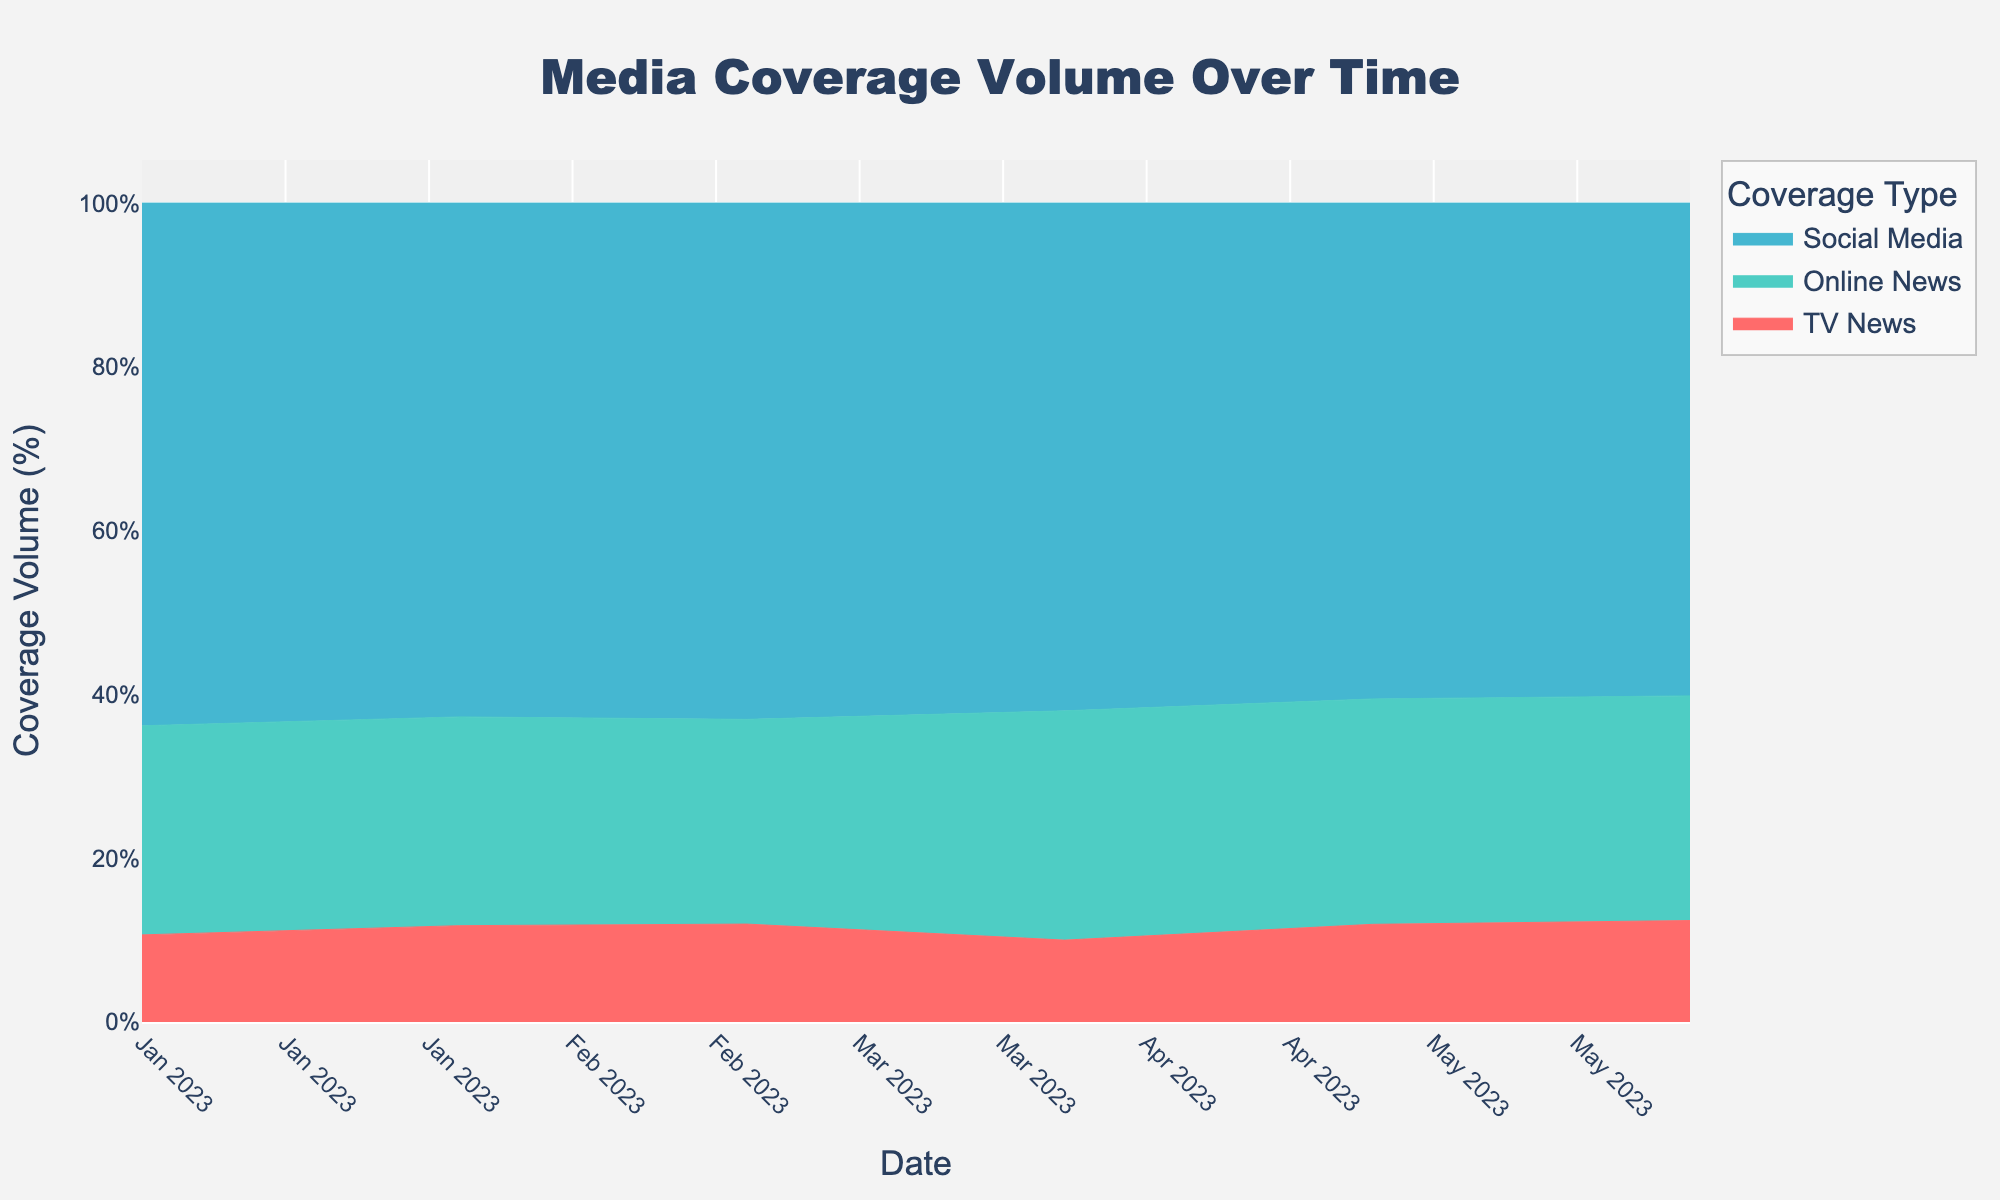When is the peak coverage volume for TV News? Looking at the plot, identify the timeframe where TV News (represented by one of the colors) reaches its highest volume. The peak for TV News is in June 2023.
Answer: June 2023 Which month had the highest overall media coverage? To determine this, sum up the coverage volumes of TV News, Online News, and Social Media for each month and compare them. June 2023 has the highest aggregated media coverage when all three types are combined.
Answer: June 2023 What is the trend of sentiment scores for TV News from January to June 2023? Analyze the pattern of sentiment scores for TV News over time by looking at the y-axis values. The sentiment score for TV News shows an increasing trend from January to June 2023.
Answer: Increasing How does the sentiment score of social media coverage compare to TV News in March 2023? Look at the sentiment scores for both social media and TV News in March. The sentiment score for Social Media (0.45) is lower than that for TV News (0.65) in March 2023.
Answer: Lower Which media coverage type showed the most significant increase in volume from January to June 2023? Compare the coverage volumes of TV News, Online News, and Social Media in January and then in June, and determine which has the largest increase. Social Media showed the most significant increase in volume from 300 in January to 340 in June.
Answer: Social Media Was there any month where online news coverage volume was greater than social media coverage volume? By closely examining the plot, compare the online news and social media coverage volumes for all months. There was no month where the online news coverage volume was greater than social media coverage volume.
Answer: No What percentage growth did Online News coverage volume experience from January to June 2023? Calculate the percentage change using the formula ((new value - old value) / old value) * 100. The volumes for Online News in January (120) and June (155) give a percentage change of ((155 - 120) / 120) * 100 = 29.2%.
Answer: 29.2% Which month experienced a dip in TV News coverage volume compared to the previous month? Investigate the changes in TV News coverage volume month-by-month. There is a dip in March 2023 compared to February 2023 (from 60 to 55).
Answer: March 2023 